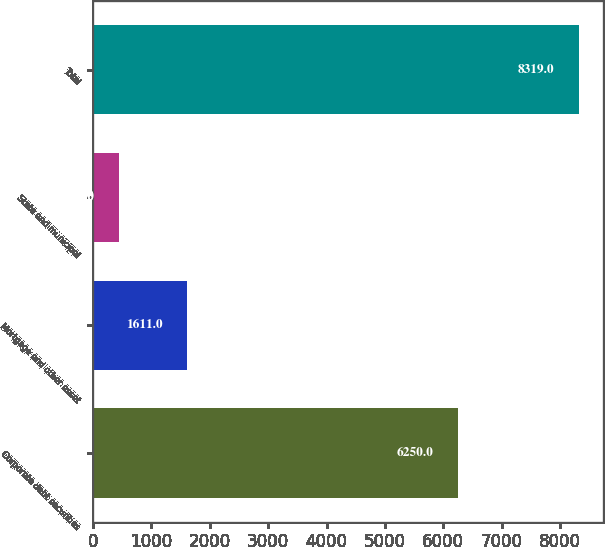<chart> <loc_0><loc_0><loc_500><loc_500><bar_chart><fcel>Corporate debt securities<fcel>Mortgage and other asset<fcel>State and municipal<fcel>Total<nl><fcel>6250<fcel>1611<fcel>438<fcel>8319<nl></chart> 